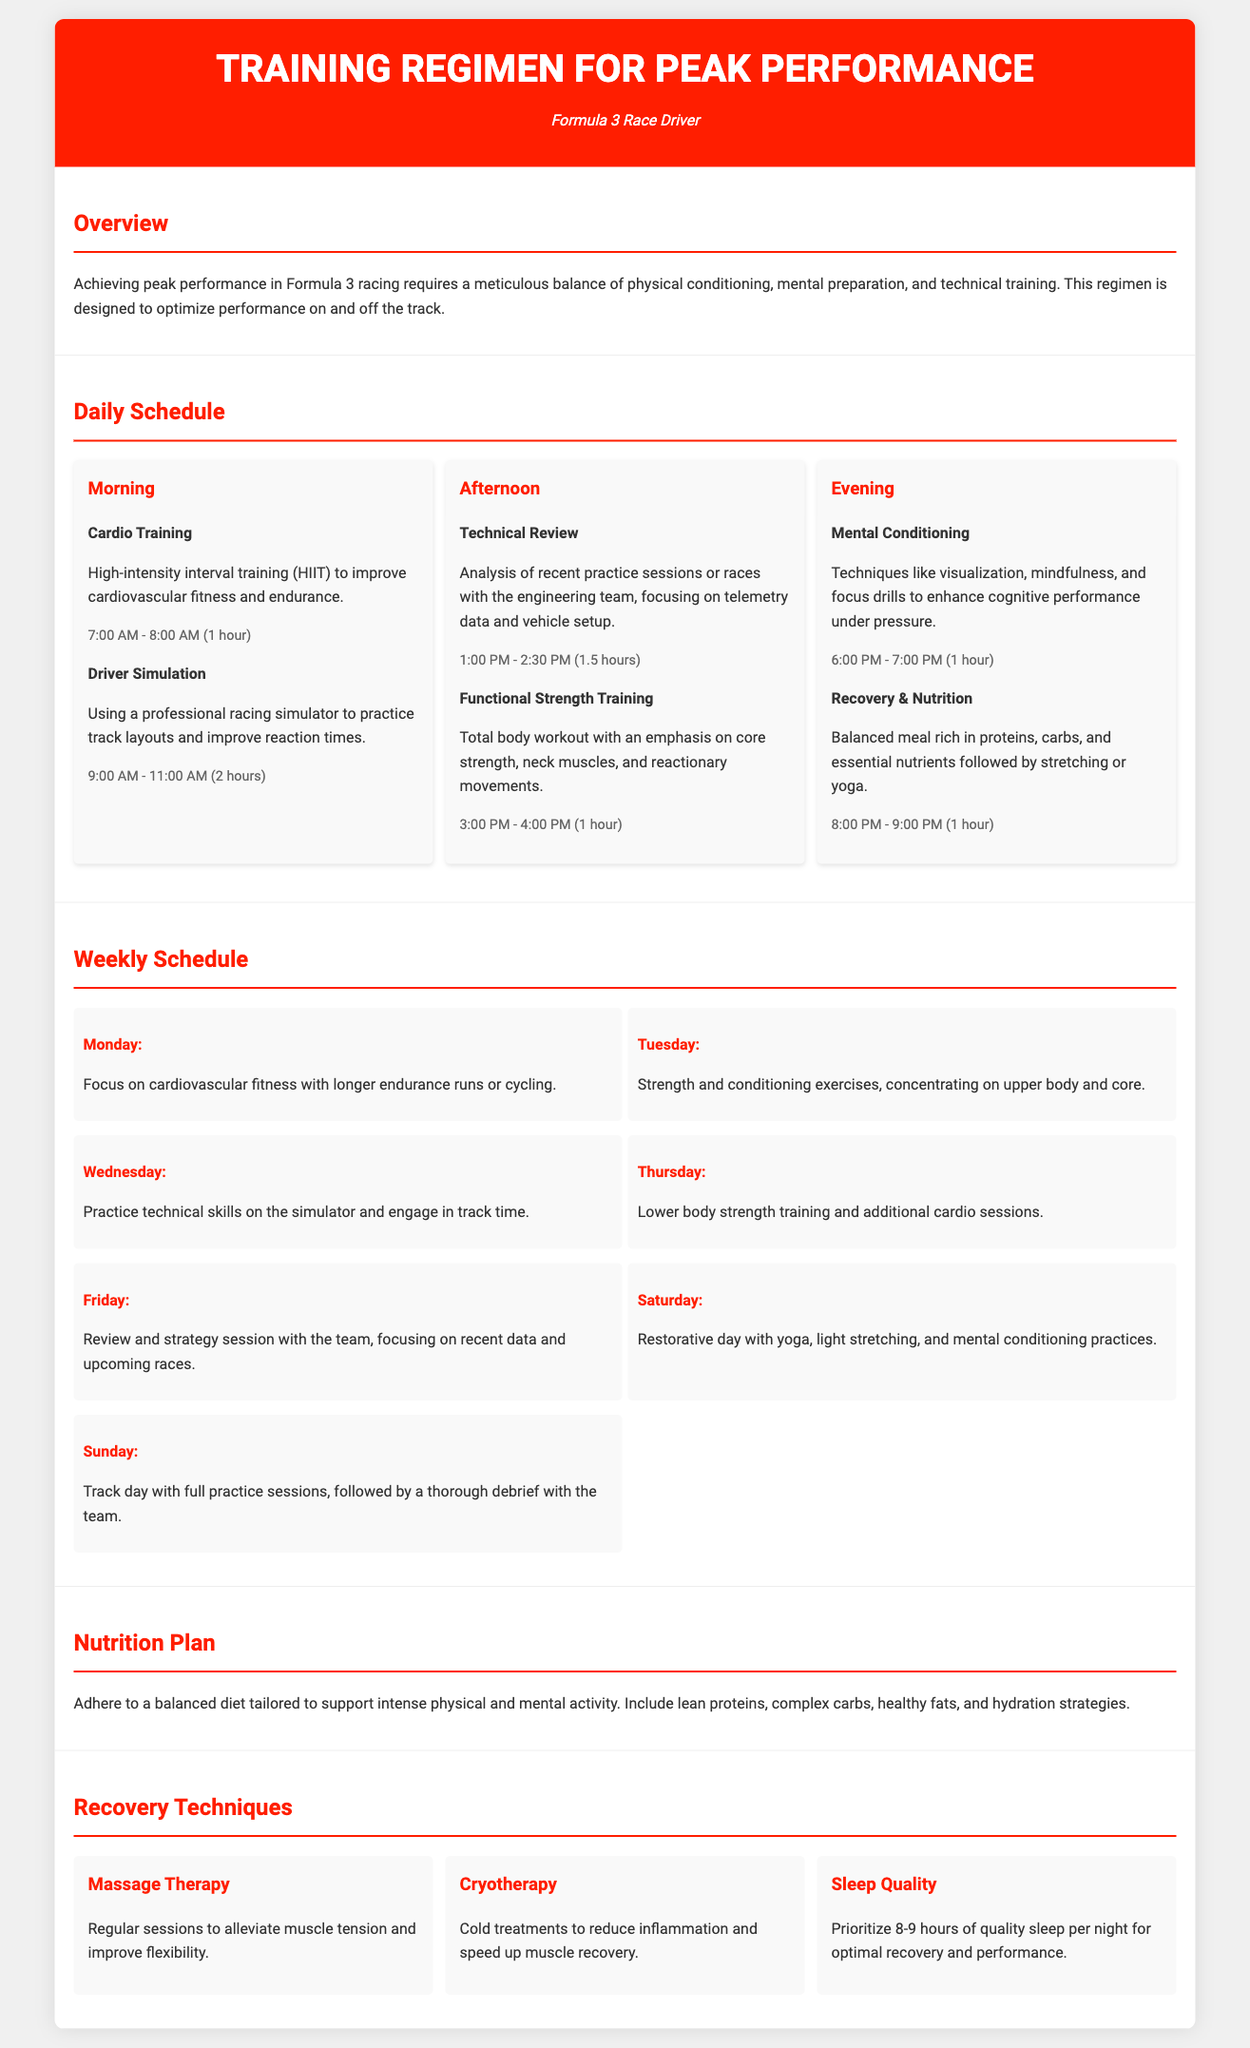what time does cardio training start? Cardio training starts at 7:00 AM, as indicated in the daily schedule.
Answer: 7:00 AM how long is the driver simulation session? The driver simulation session lasts for 2 hours, from 9:00 AM to 11:00 AM.
Answer: 2 hours what is the focus of training on Wednesday? On Wednesday, the focus is on practicing technical skills on the simulator and engaging in track time.
Answer: Technical skills how many hours of mental conditioning are scheduled in the evening? Mental conditioning is scheduled for 1 hour, from 6:00 PM to 7:00 PM.
Answer: 1 hour what type of training occurs on Friday? On Friday, a review and strategy session with the team is conducted, focusing on recent data and upcoming races.
Answer: Review and strategy session what recovery technique emphasizes sleep? The recovery technique that emphasizes sleep is "Sleep Quality".
Answer: Sleep Quality how many days of the week are focused on strength training? There are three days (Tuesday, Thursday, and training on the track) that involve strength training in the weekly schedule.
Answer: Three days what is the primary goal of the training regimen? The primary goal is to optimize performance on and off the track.
Answer: Optimize performance which meal component is highlighted in the nutrition plan? The nutrition plan highlights the importance of lean proteins as a meal component.
Answer: Lean proteins 